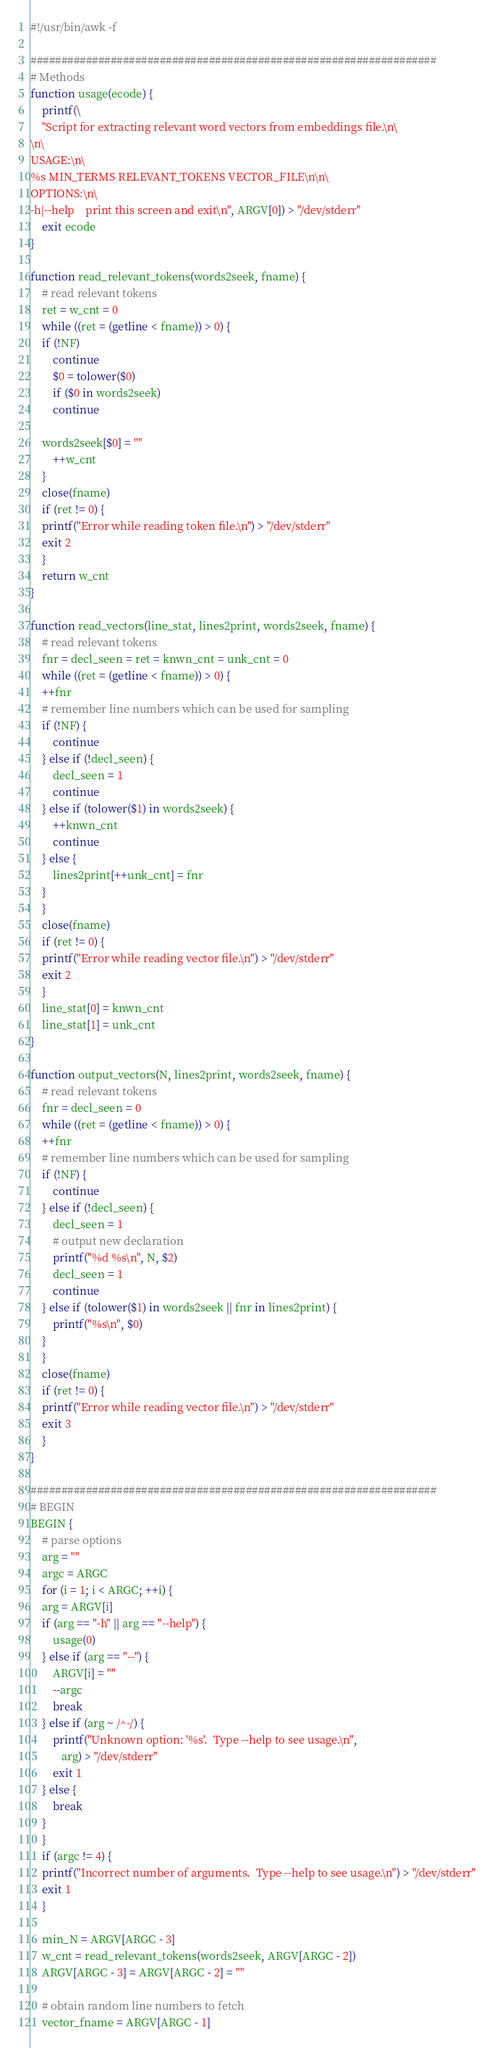<code> <loc_0><loc_0><loc_500><loc_500><_Awk_>#!/usr/bin/awk -f

##################################################################
# Methods
function usage(ecode) {
    printf(\
	"Script for extracting relevant word vectors from embeddings file.\n\
\n\
USAGE:\n\
%s MIN_TERMS RELEVANT_TOKENS VECTOR_FILE\n\n\
OPTIONS:\n\
-h|--help    print this screen and exit\n", ARGV[0]) > "/dev/stderr"
    exit ecode
}

function read_relevant_tokens(words2seek, fname) {
    # read relevant tokens
    ret = w_cnt = 0
    while ((ret = (getline < fname)) > 0) {
	if (!NF)
	    continue
        $0 = tolower($0)
        if ($0 in words2seek)
	    continue

	words2seek[$0] = ""
        ++w_cnt
    }
    close(fname)
    if (ret != 0) {
	printf("Error while reading token file.\n") > "/dev/stderr"
	exit 2
    }
    return w_cnt
}

function read_vectors(line_stat, lines2print, words2seek, fname) {
    # read relevant tokens
    fnr = decl_seen = ret = knwn_cnt = unk_cnt = 0
    while ((ret = (getline < fname)) > 0) {
	++fnr
	# remember line numbers which can be used for sampling
	if (!NF) {
	    continue
	} else if (!decl_seen) {
	    decl_seen = 1
	    continue
	} else if (tolower($1) in words2seek) {
	    ++knwn_cnt
	    continue
	} else {
	    lines2print[++unk_cnt] = fnr
	}
    }
    close(fname)
    if (ret != 0) {
	printf("Error while reading vector file.\n") > "/dev/stderr"
	exit 2
    }
    line_stat[0] = knwn_cnt
    line_stat[1] = unk_cnt
}

function output_vectors(N, lines2print, words2seek, fname) {
    # read relevant tokens
    fnr = decl_seen = 0
    while ((ret = (getline < fname)) > 0) {
	++fnr
	# remember line numbers which can be used for sampling
	if (!NF) {
	    continue
	} else if (!decl_seen) {
	    decl_seen = 1
	    # output new declaration
	    printf("%d %s\n", N, $2)
	    decl_seen = 1
	    continue
	} else if (tolower($1) in words2seek || fnr in lines2print) {
	    printf("%s\n", $0)
	}
    }
    close(fname)
    if (ret != 0) {
	printf("Error while reading vector file.\n") > "/dev/stderr"
	exit 3
    }
}

##################################################################
# BEGIN
BEGIN {
    # parse options
    arg = ""
    argc = ARGC
    for (i = 1; i < ARGC; ++i) {
	arg = ARGV[i]
	if (arg == "-h" || arg == "--help") {
	    usage(0)
	} else if (arg == "--") {
	    ARGV[i] = ""
	    --argc
	    break
	} else if (arg ~ /^-/) {
	    printf("Unknown option: '%s'.  Type --help to see usage.\n",
		   arg) > "/dev/stderr"
	    exit 1
	} else {
	    break
	}
    }
    if (argc != 4) {
	printf("Incorrect number of arguments.  Type --help to see usage.\n") > "/dev/stderr"
	exit 1
    }

    min_N = ARGV[ARGC - 3]
    w_cnt = read_relevant_tokens(words2seek, ARGV[ARGC - 2])
    ARGV[ARGC - 3] = ARGV[ARGC - 2] = ""

    # obtain random line numbers to fetch
    vector_fname = ARGV[ARGC - 1]</code> 